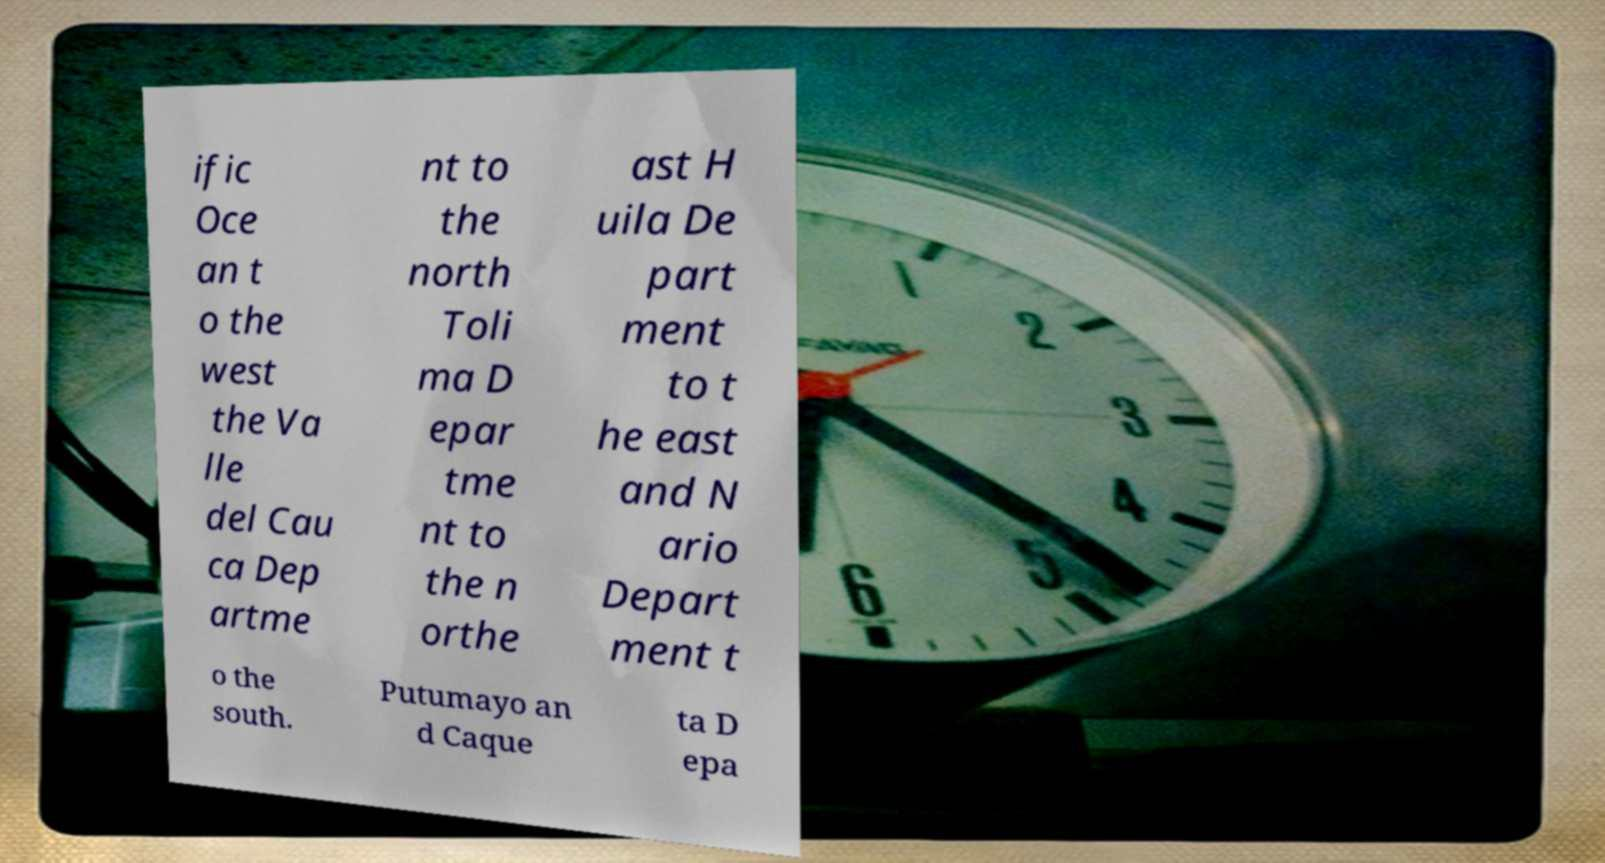Can you read and provide the text displayed in the image?This photo seems to have some interesting text. Can you extract and type it out for me? ific Oce an t o the west the Va lle del Cau ca Dep artme nt to the north Toli ma D epar tme nt to the n orthe ast H uila De part ment to t he east and N ario Depart ment t o the south. Putumayo an d Caque ta D epa 